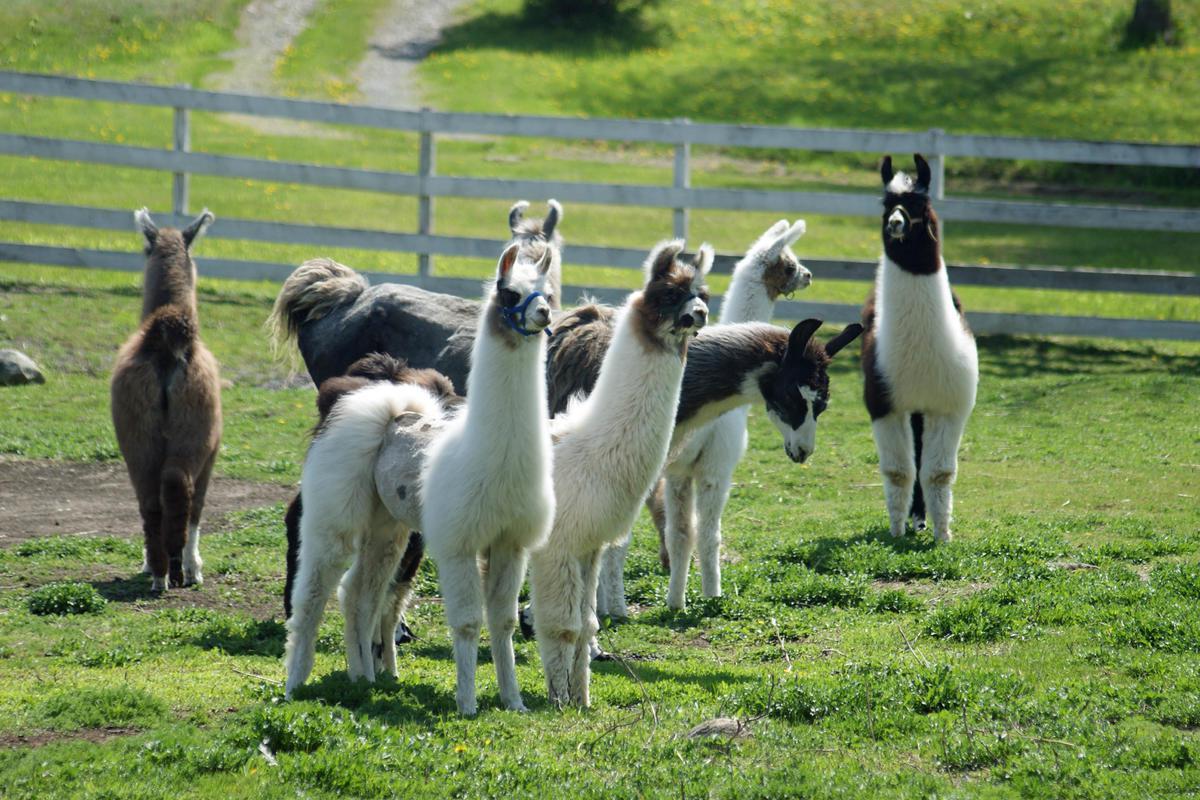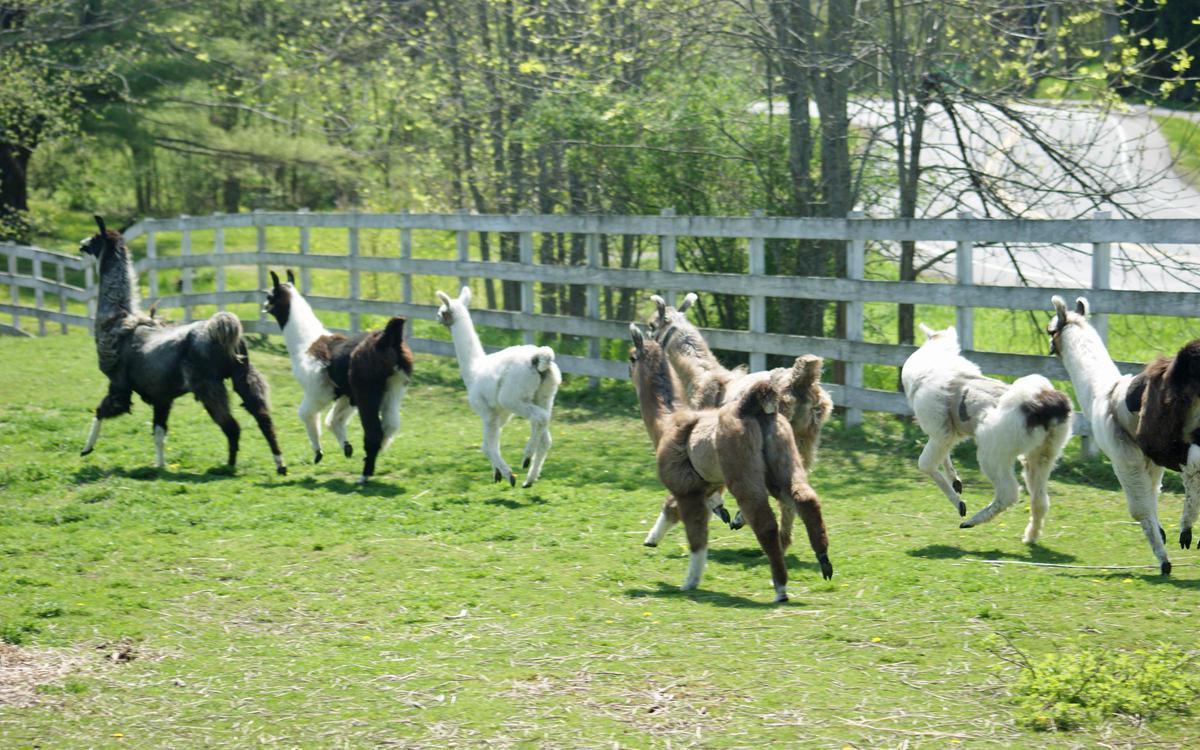The first image is the image on the left, the second image is the image on the right. Given the left and right images, does the statement "Four or fewer llamas are visible." hold true? Answer yes or no. No. 